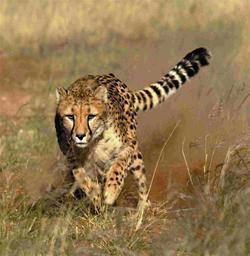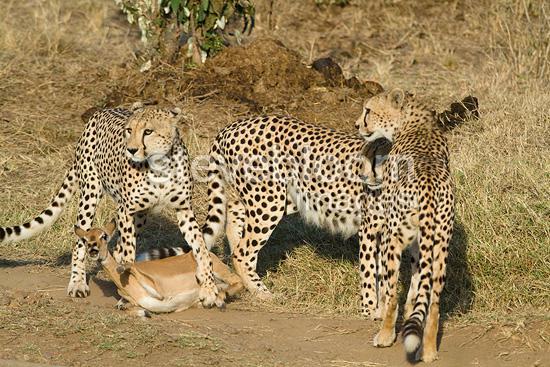The first image is the image on the left, the second image is the image on the right. Examine the images to the left and right. Is the description "In one of the images there is a single leopard running." accurate? Answer yes or no. Yes. The first image is the image on the left, the second image is the image on the right. For the images shown, is this caption "There are three total cheetahs." true? Answer yes or no. No. 